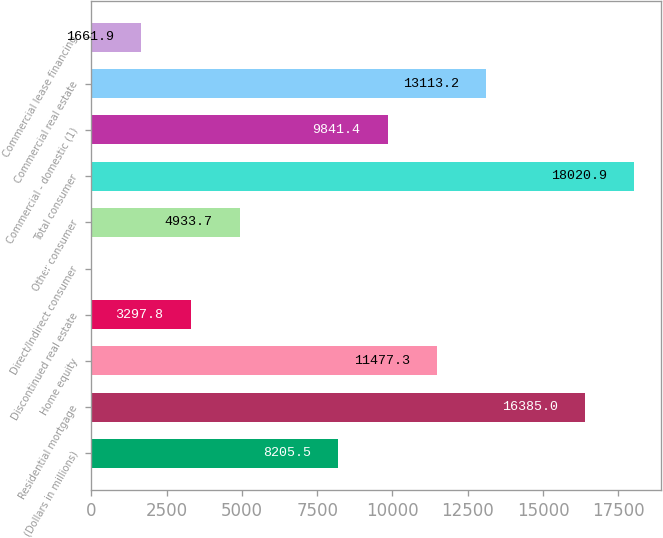Convert chart to OTSL. <chart><loc_0><loc_0><loc_500><loc_500><bar_chart><fcel>(Dollars in millions)<fcel>Residential mortgage<fcel>Home equity<fcel>Discontinued real estate<fcel>Direct/Indirect consumer<fcel>Other consumer<fcel>Total consumer<fcel>Commercial - domestic (1)<fcel>Commercial real estate<fcel>Commercial lease financing<nl><fcel>8205.5<fcel>16385<fcel>11477.3<fcel>3297.8<fcel>26<fcel>4933.7<fcel>18020.9<fcel>9841.4<fcel>13113.2<fcel>1661.9<nl></chart> 